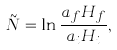<formula> <loc_0><loc_0><loc_500><loc_500>\tilde { N } = \ln \frac { a _ { f } H _ { f } } { a _ { i } H _ { i } } ,</formula> 